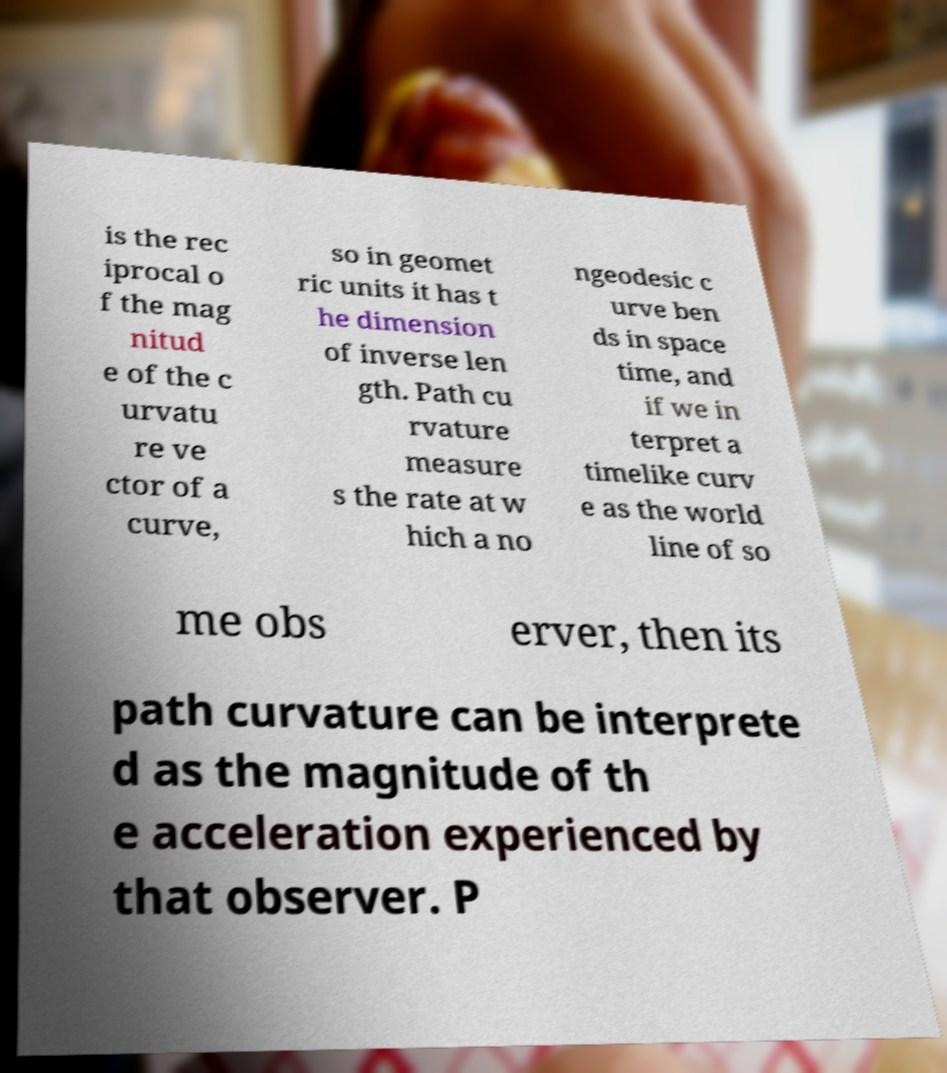Please read and relay the text visible in this image. What does it say? is the rec iprocal o f the mag nitud e of the c urvatu re ve ctor of a curve, so in geomet ric units it has t he dimension of inverse len gth. Path cu rvature measure s the rate at w hich a no ngeodesic c urve ben ds in space time, and if we in terpret a timelike curv e as the world line of so me obs erver, then its path curvature can be interprete d as the magnitude of th e acceleration experienced by that observer. P 